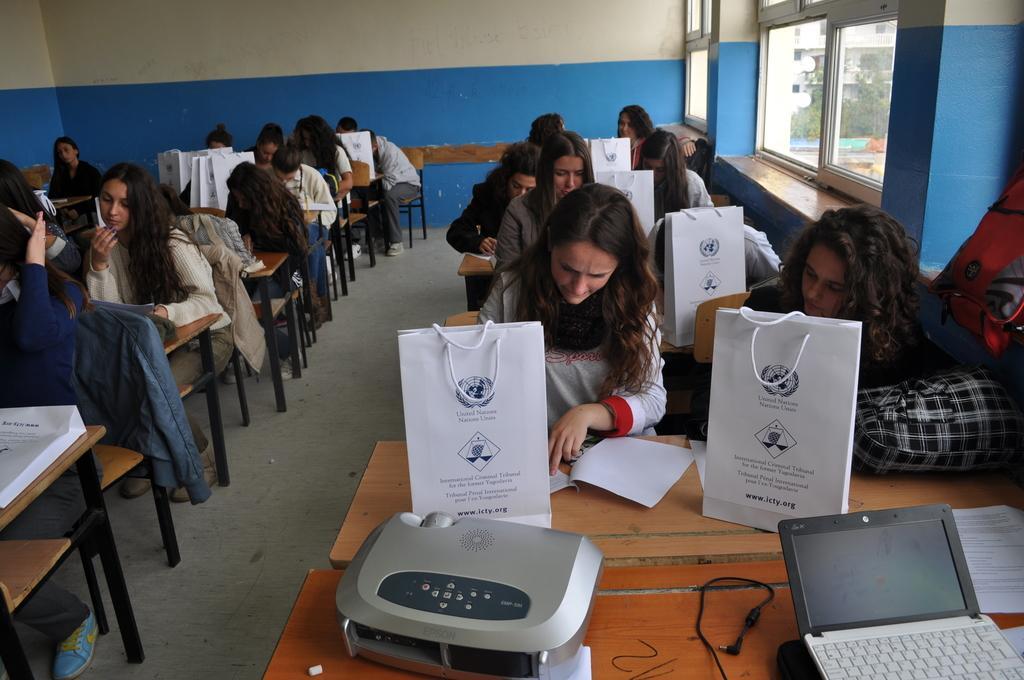Can you describe this image briefly? Here in this picture we can see number of women sitting on chairs with table in front of them in the room over there and in the front on the table we can see a printing machine and a laptop present and on the tables we can see covers present and all the women are seeing something in the papers present on the table in front of them over there and on the right side we can see windows present on the room over there and through that we can see buildings and plants and trees present over there. 